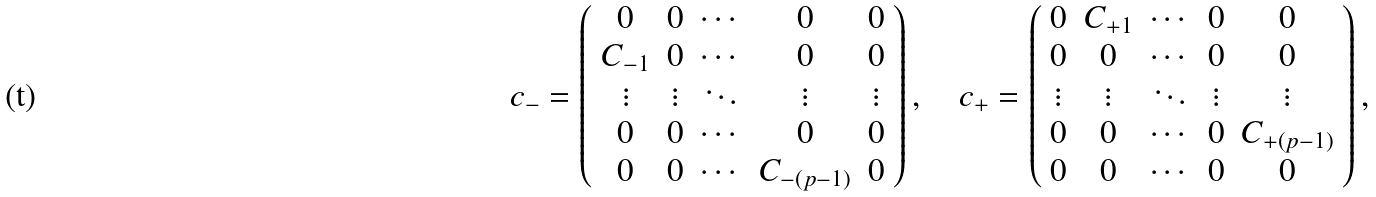Convert formula to latex. <formula><loc_0><loc_0><loc_500><loc_500>c _ { - } = \left ( \begin{array} { c c c c c } 0 & 0 & \cdots & 0 & 0 \\ C _ { - 1 } & 0 & \cdots & 0 & 0 \\ \vdots & \vdots & \ddots & \vdots & \vdots \\ 0 & 0 & \cdots & 0 & 0 \\ 0 & 0 & \cdots & C _ { - ( p - 1 ) } & 0 \end{array} \right ) , \quad c _ { + } = \left ( \begin{array} { c c c c c } 0 & C _ { + 1 } & \cdots & 0 & 0 \\ 0 & 0 & \cdots & 0 & 0 \\ \vdots & \vdots & \ddots & \vdots & \vdots \\ 0 & 0 & \cdots & 0 & C _ { + ( p - 1 ) } \\ 0 & 0 & \cdots & 0 & 0 \end{array} \right ) ,</formula> 